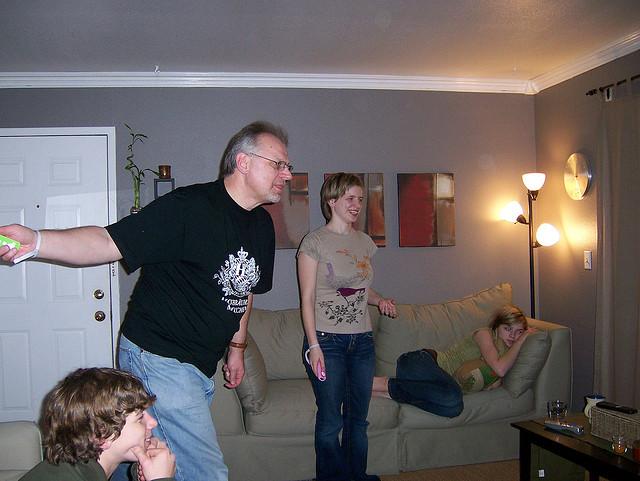How many persons are wearing glasses?
Keep it brief. 1. What are the people watching?
Concise answer only. Tv. Are the lights on?
Keep it brief. Yes. Is there a person laying on the couch?
Keep it brief. Yes. Are the guy and girl holding gaming controllers?
Answer briefly. Yes. 